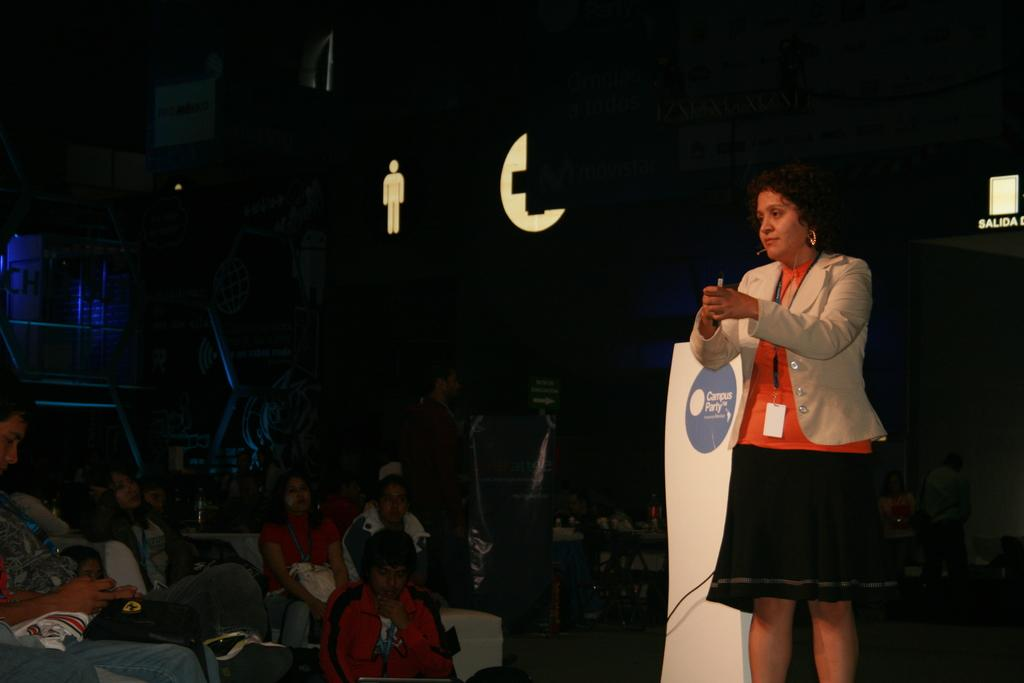What is the main subject on the right side of the image? There is a woman standing on a dais on the right side of the image. Can you describe the people in the background of the image? There are people sitting on chairs in the background of the image. What type of snake can be seen slithering on the woman's ear in the image? There is no snake present in the image, and the woman's ear is not mentioned in the provided facts. 